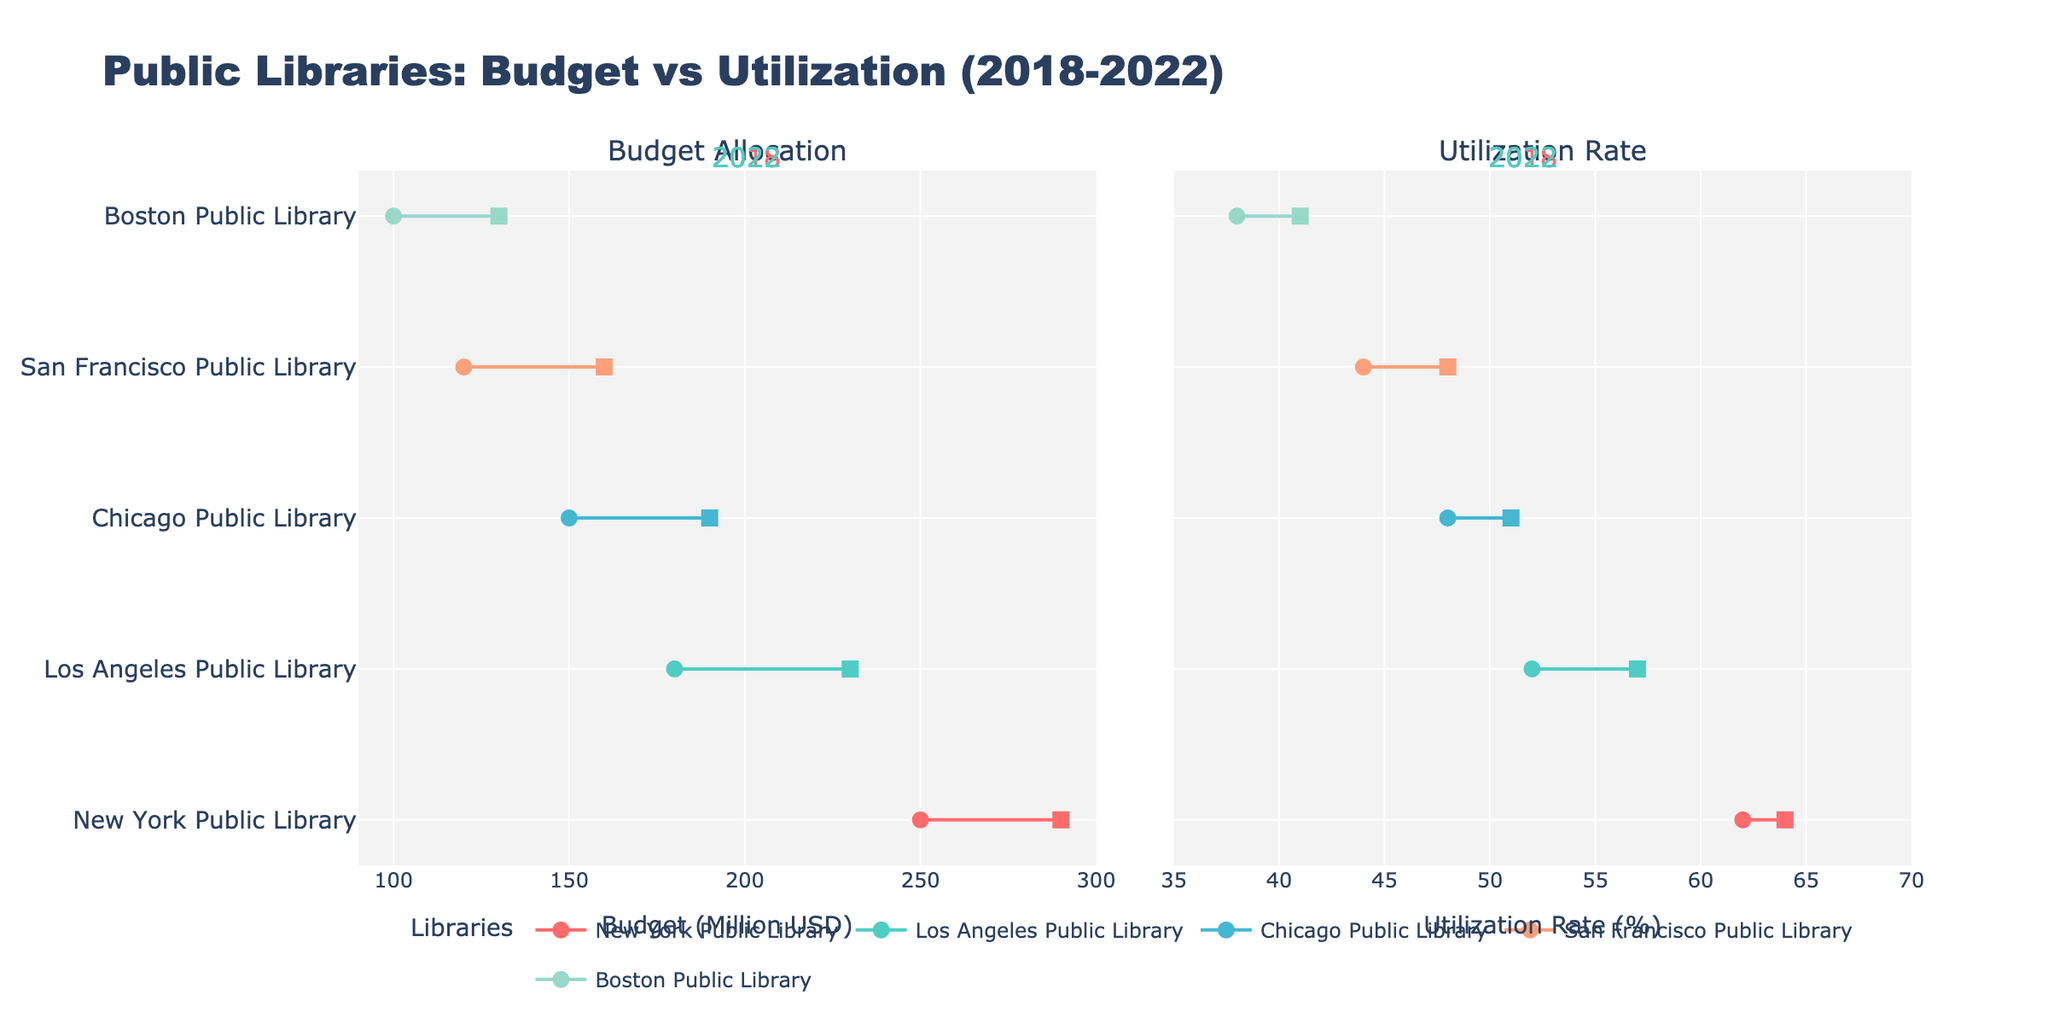What's the title of the plot? The title is mentioned at the top of the plot and it reads "Public Libraries: Budget vs Utilization (2018-2022)".
Answer: Public Libraries: Budget vs Utilization (2018-2022) What are the two subplots named? The subtitles are provided at the top of each subplot; the left one is "Budget Allocation" and the right one is "Utilization Rate".
Answer: Budget Allocation, Utilization Rate How many libraries are compared in the plot? The y-axis lists the libraries being compared. There are five libraries: New York Public Library, Los Angeles Public Library, Chicago Public Library, San Francisco Public Library, and Boston Public Library.
Answer: 5 Which library had the highest Budget Allocation in 2022? Observing the farthest right data points in the "Budget Allocation" subplot, New York Public Library has the highest budget allocation at 290 million USD.
Answer: New York Public Library Did any library show a decrease in Utilization Rate from 2018 to 2022? By looking at the lines connecting the 2018 and 2022 points in the "Utilization Rate" subplot, New York Public Library shows a decrease in utilization rate from 62% to 64%.
Answer: No What is the difference in the Budget Allocation between 2018 and 2022 for the Boston Public Library? In the subplot "Budget Allocation", Boston Public Library has a budget allocation of 100 million USD in 2018 and 130 million USD in 2022. The difference is 130 - 100 = 30 million USD.
Answer: 30 million USD Which library has the smallest increase in Utilization Rate from 2018 to 2022? Comparing the deltas in the "Utilization Rate" subplot, Boston Public Library has the smallest increase, moving from 38% in 2018 to 41% in 2022, which is 3%.
Answer: Boston Public Library Are the Utilization Rates of any two libraries the same in 2022? Checking the "Utilization Rate" subplot for 2022 data points, both New York Public Library and Los Angeles Public Library have a utilization rate of 64% and 57% respectively, but no two libraries have the same utilization rate.
Answer: No 